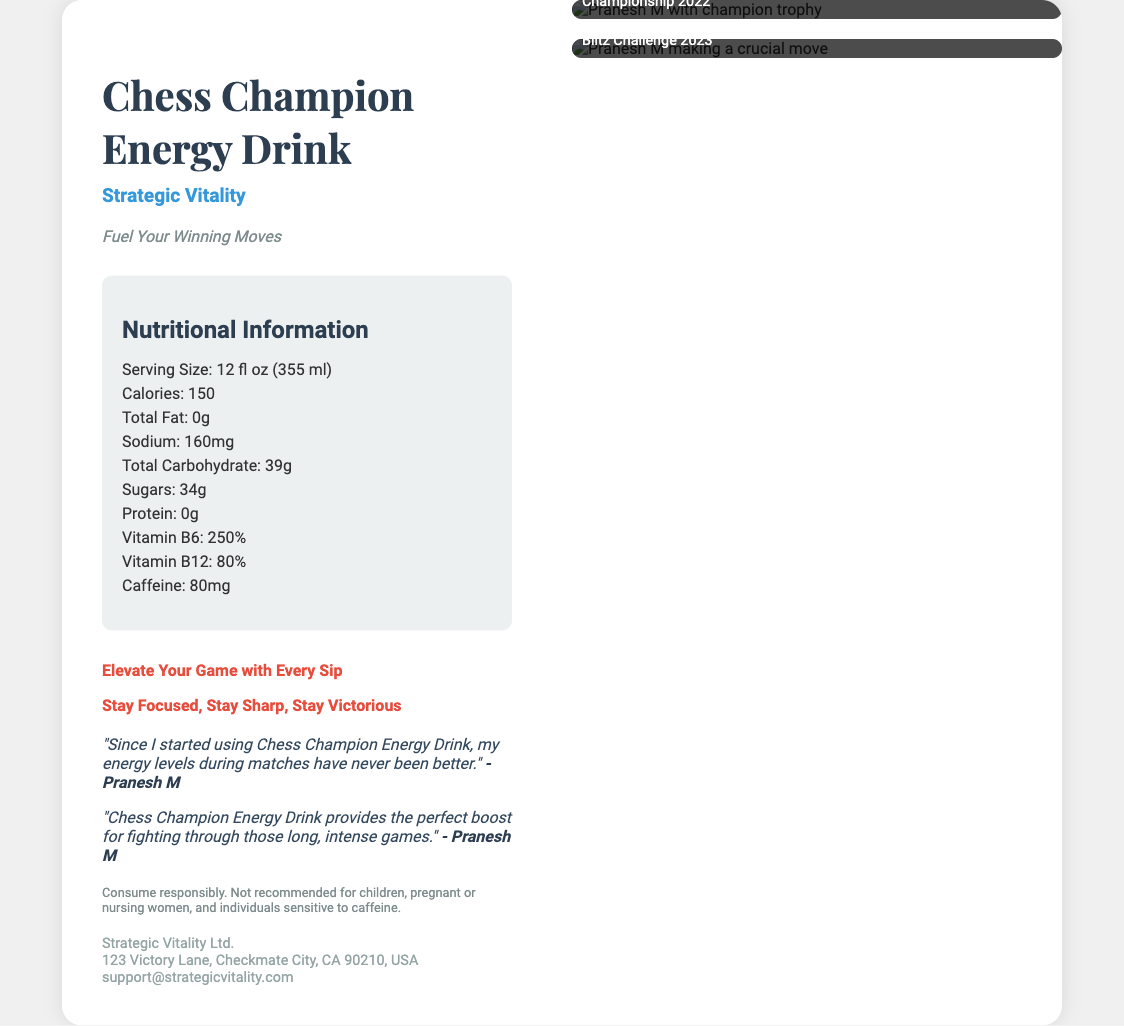What is the brand of the energy drink? The brand is mentioned in the product info section of the document.
Answer: Strategic Vitality What is the serving size of the drink? The serving size is found in the nutritional information section.
Answer: 12 fl oz (355 ml) How much caffeine is in the drink? The caffeine content is listed in the nutritional information.
Answer: 80mg Who is quoted in the document? The quotes mention the individual who uses the product.
Answer: Pranesh M What championship did Pranesh M win in 2022? The document includes visuals and descriptions of Pranesh M's achievements.
Answer: World Junior Chess Championship How many grams of total carbohydrates are in the drink? This is specified in the nutritional information section.
Answer: 39g What is the tagline of the product? The tagline is prominently displayed in the product information.
Answer: Fuel Your Winning Moves What year did Pranesh M participate in the Grandmaster Blitz Challenge? This is stated in the photo descriptions.
Answer: 2023 How many vitamins are explicitly listed in the nutritional information? The document provides specific vitamin contents in the nutrient list.
Answer: 2 (Vitamin B6 and Vitamin B12) 